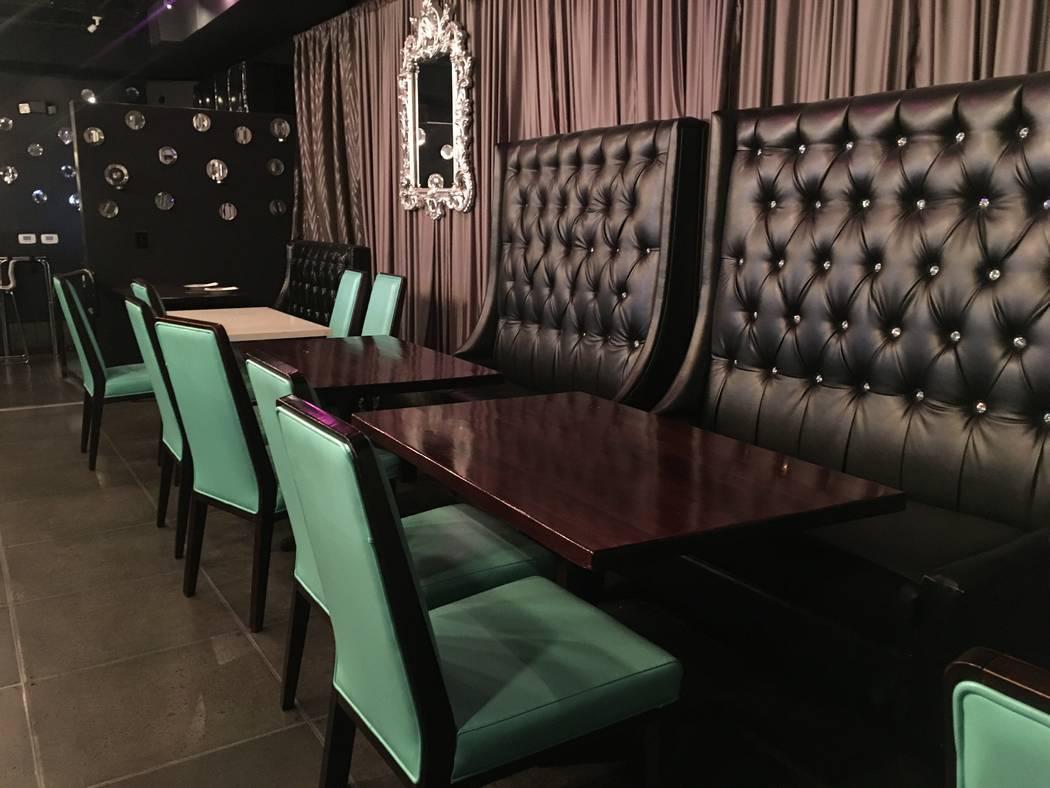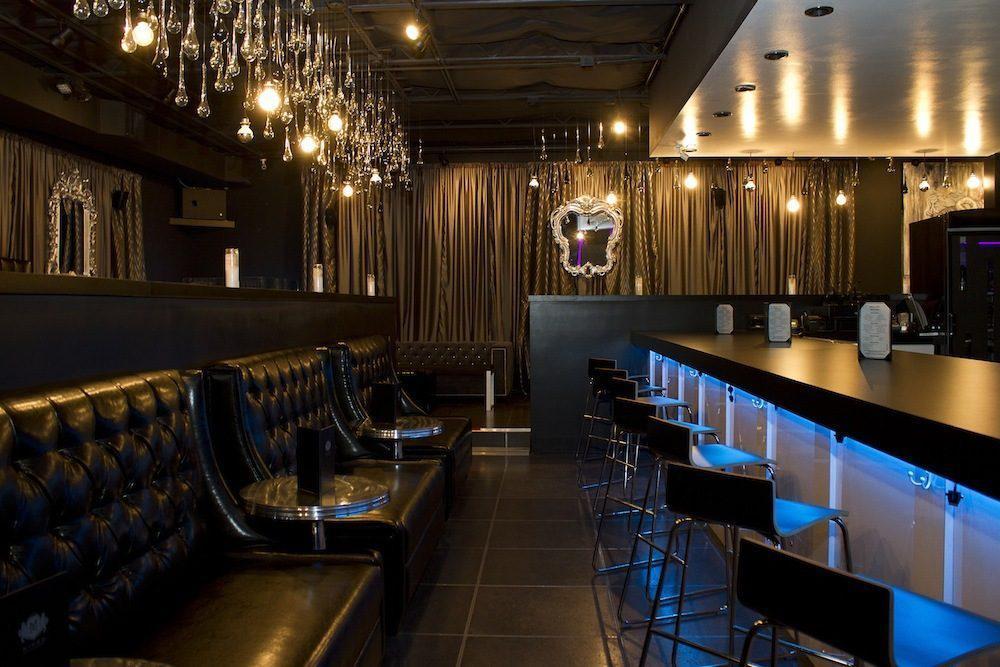The first image is the image on the left, the second image is the image on the right. Given the left and right images, does the statement "You can see barstools in one of the images." hold true? Answer yes or no. Yes. The first image is the image on the left, the second image is the image on the right. Given the left and right images, does the statement "The right image shows a line of black benches with tufted backs in front of a low divider wall with a curtain behind it, and under lit hanging lights." hold true? Answer yes or no. Yes. 